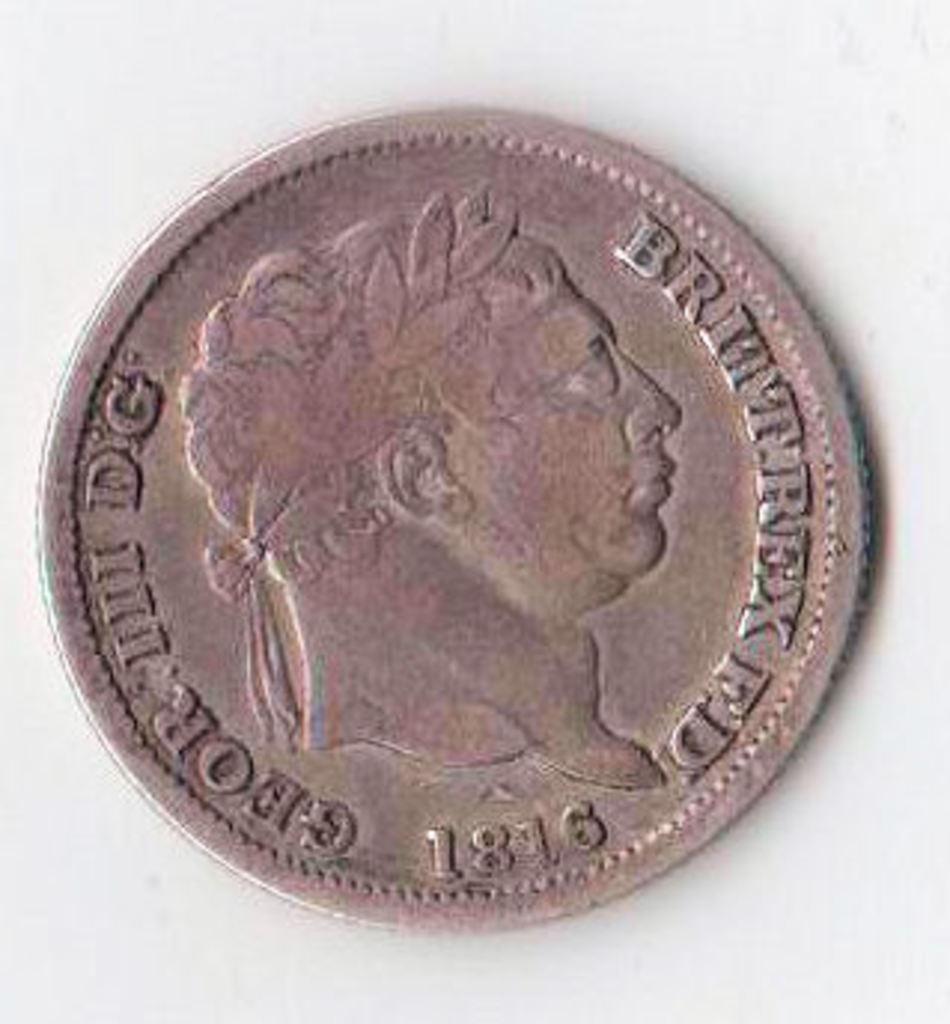What is written on the coin?
Offer a very short reply. Brittrex fd 1816 geroiii dg. What year is the coin from?
Your response must be concise. 1816. 